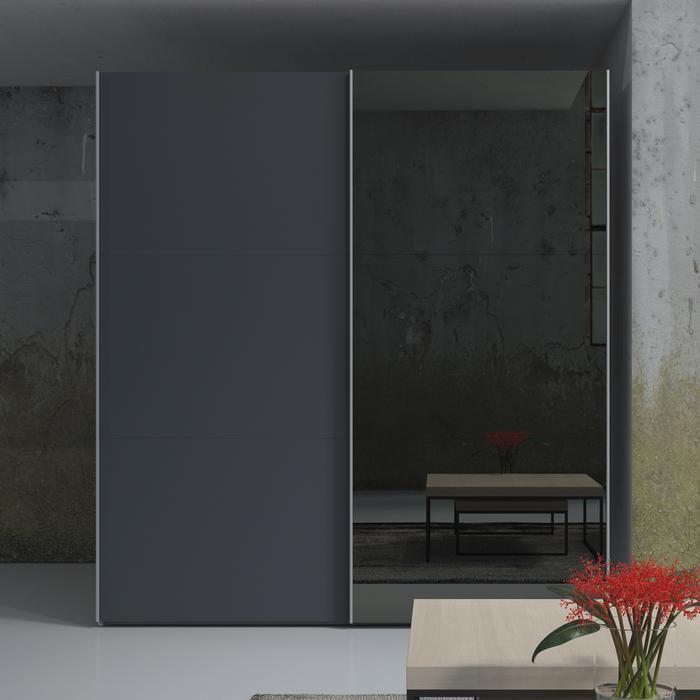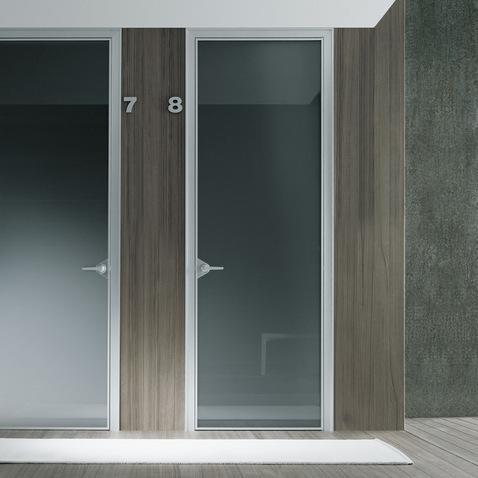The first image is the image on the left, the second image is the image on the right. Given the left and right images, does the statement "An image shows a wardrobe with partly open doors revealing items and shelves inside." hold true? Answer yes or no. No. 